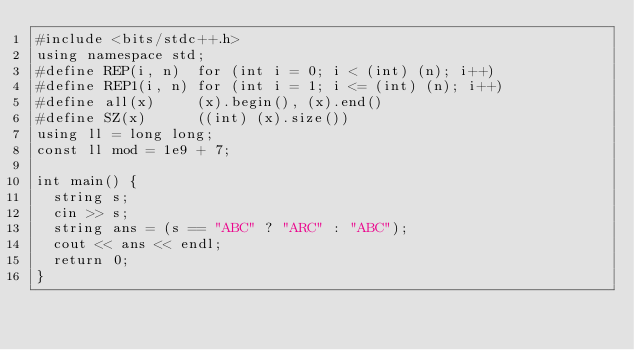<code> <loc_0><loc_0><loc_500><loc_500><_C++_>#include <bits/stdc++.h>
using namespace std;
#define REP(i, n)  for (int i = 0; i < (int) (n); i++)
#define REP1(i, n) for (int i = 1; i <= (int) (n); i++)
#define all(x)     (x).begin(), (x).end()
#define SZ(x)      ((int) (x).size())
using ll = long long;
const ll mod = 1e9 + 7;

int main() {
  string s;
  cin >> s;
  string ans = (s == "ABC" ? "ARC" : "ABC");
  cout << ans << endl;
  return 0;
}
</code> 